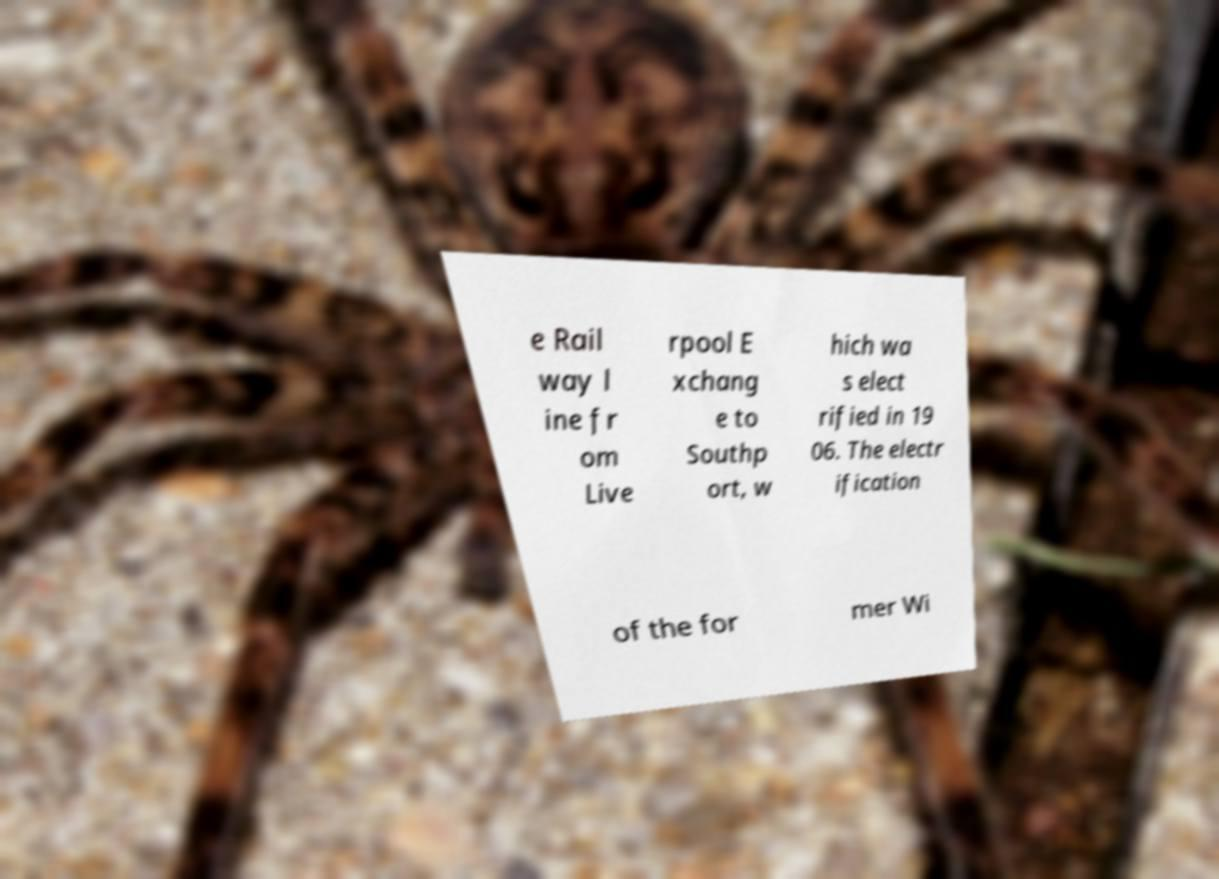Please read and relay the text visible in this image. What does it say? e Rail way l ine fr om Live rpool E xchang e to Southp ort, w hich wa s elect rified in 19 06. The electr ification of the for mer Wi 